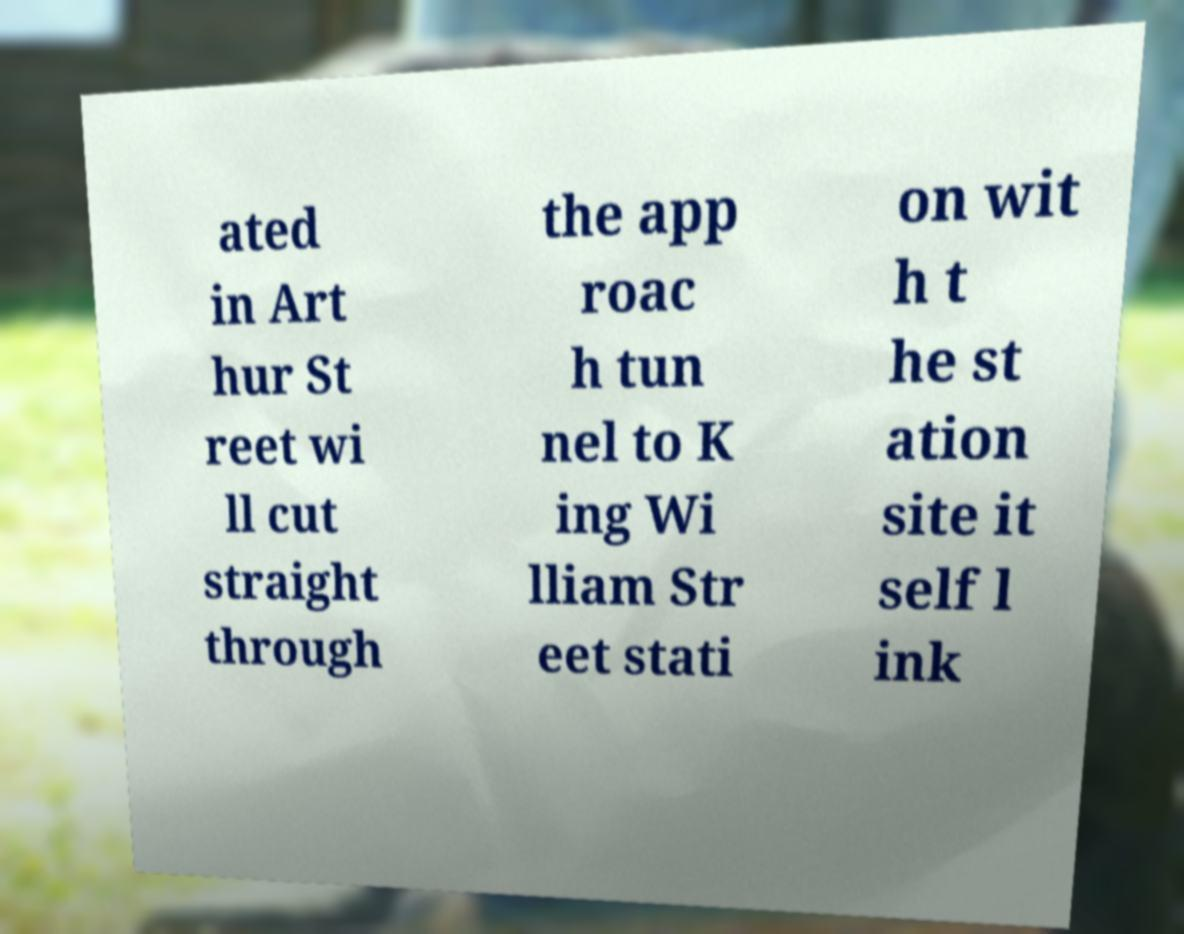I need the written content from this picture converted into text. Can you do that? ated in Art hur St reet wi ll cut straight through the app roac h tun nel to K ing Wi lliam Str eet stati on wit h t he st ation site it self l ink 